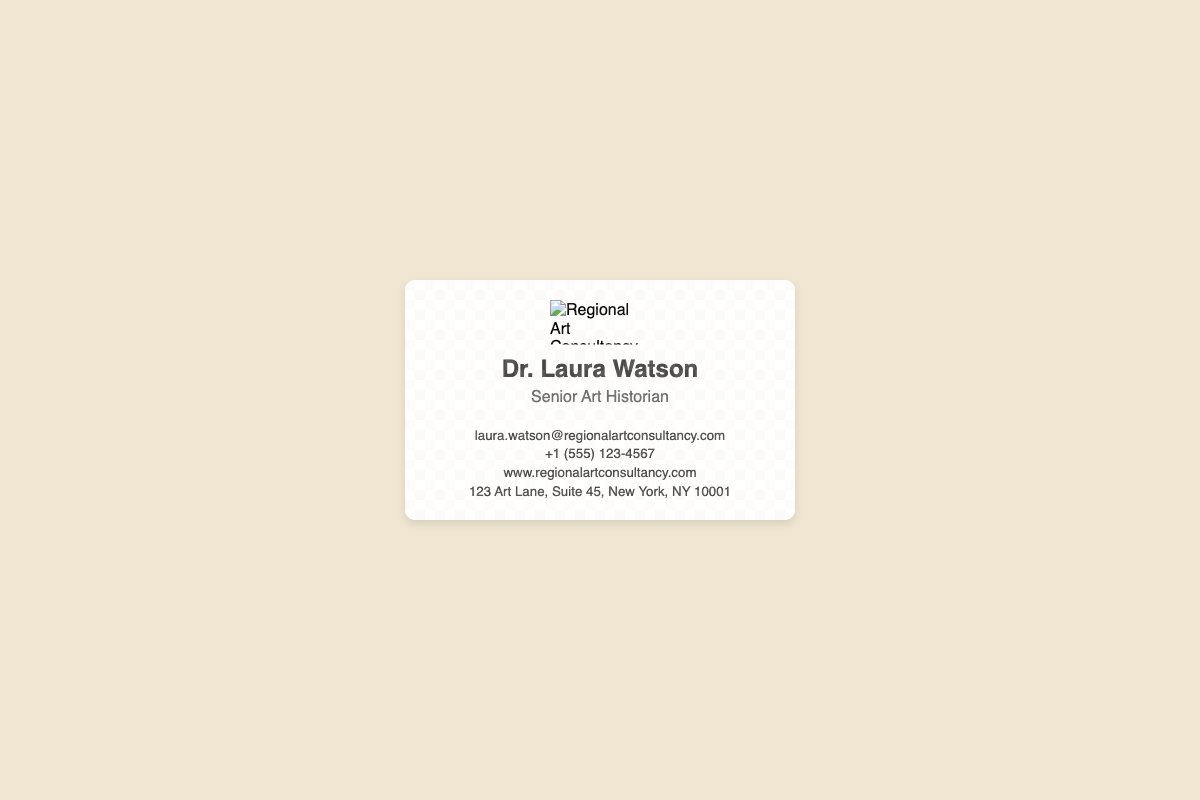What is the name of the advisor? The advisor’s name is prominently displayed on the business card.
Answer: Dr. Laura Watson What is the advisor's position? The position is listed right below the advisor's name on the business card.
Answer: Senior Art Historian What is the email address of the advisor? The email address can be found in the contact details section of the business card.
Answer: laura.watson@regionalartconsultancy.com What is the phone number provided? The phone number is included in the contact information section of the card.
Answer: +1 (555) 123-4567 What is the website URL? The website URL is clearly stated in the contact details on the business card.
Answer: www.regionalartconsultancy.com What city is the office located in? The city is mentioned in the address section of the contact details.
Answer: New York How does the business card highlight regional influences? The card represents specialization in regional art movements through its design elements and text.
Answer: Regional Art Consultancy What type of business document is this? The document type can be identified by its layout and purpose.
Answer: Business card What is the dominant color of the background? The background color of the document is indicated in the style section of the code.
Answer: #f0e6d2 